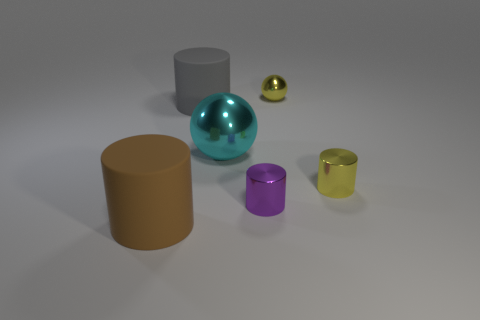Subtract 1 cylinders. How many cylinders are left? 3 Subtract all cyan spheres. Subtract all cyan cubes. How many spheres are left? 1 Add 3 big blue blocks. How many objects exist? 9 Subtract all cylinders. How many objects are left? 2 Subtract 0 red cylinders. How many objects are left? 6 Subtract all large brown matte cylinders. Subtract all metallic cylinders. How many objects are left? 3 Add 4 spheres. How many spheres are left? 6 Add 4 big yellow rubber spheres. How many big yellow rubber spheres exist? 4 